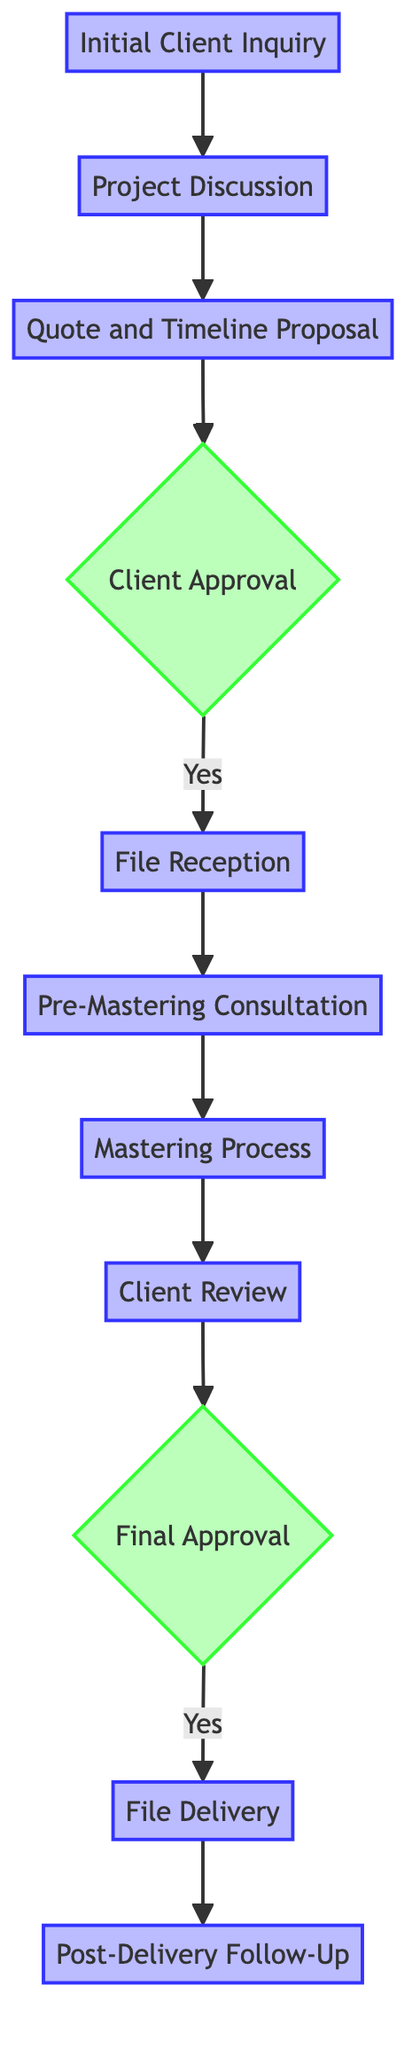What is the first step in the client communication process? The flow chart indicates that the first step is "Initial Client Inquiry." This is the starting point from which all subsequent steps follow.
Answer: Initial Client Inquiry How many steps are there in the client communication process? By counting the nodes in the flow chart, there are a total of 11 distinct steps that make up the client communication process.
Answer: 11 What is the last step in the process? The last step in the flow chart is "Post-Delivery Follow-Up," which occurs after the final delivery of mastered files.
Answer: Post-Delivery Follow-Up What happens after "Client Review"? From the diagram, after "Client Review," the next step is "Final Approval." This follows the client's review and feedback process.
Answer: Final Approval Is "Client Approval" a decision point in the process? Yes, "Client Approval" is represented as a decision node in the flow chart, indicating a binary choice based on whether the client approves or not.
Answer: Yes Describe the transition from "Quote and Timeline Proposal" to "File Reception". The flow chart shows that "File Reception" follows "Client Approval." Thus, the transition occurs only after the client has approved the quote and timeline proposal.
Answer: After Client Approval Which step follows "Mastering Process"? The step that follows "Mastering Process" is "Client Review," where the mastered tracks are sent to the client for feedback.
Answer: Client Review How does the process begin? The process begins with the "Initial Client Inquiry," marking the entry point into the mastering project communication sequence.
Answer: Initial Client Inquiry What is required for proceeding from "Final Approval" to "File Delivery"? The flow chart indicates that "File Delivery" occurs after receiving the "Final Approval" from the client and settling any outstanding payments.
Answer: Final Approval What is the purpose of "Pre-Mastering Consultation"? The purpose of the "Pre-Mastering Consultation" is to go over the mix files in detail and set the client's expectations for the mastering process.
Answer: Set expectations 